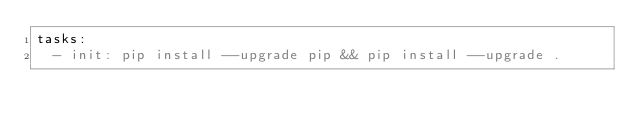<code> <loc_0><loc_0><loc_500><loc_500><_YAML_>tasks:
  - init: pip install --upgrade pip && pip install --upgrade .
</code> 